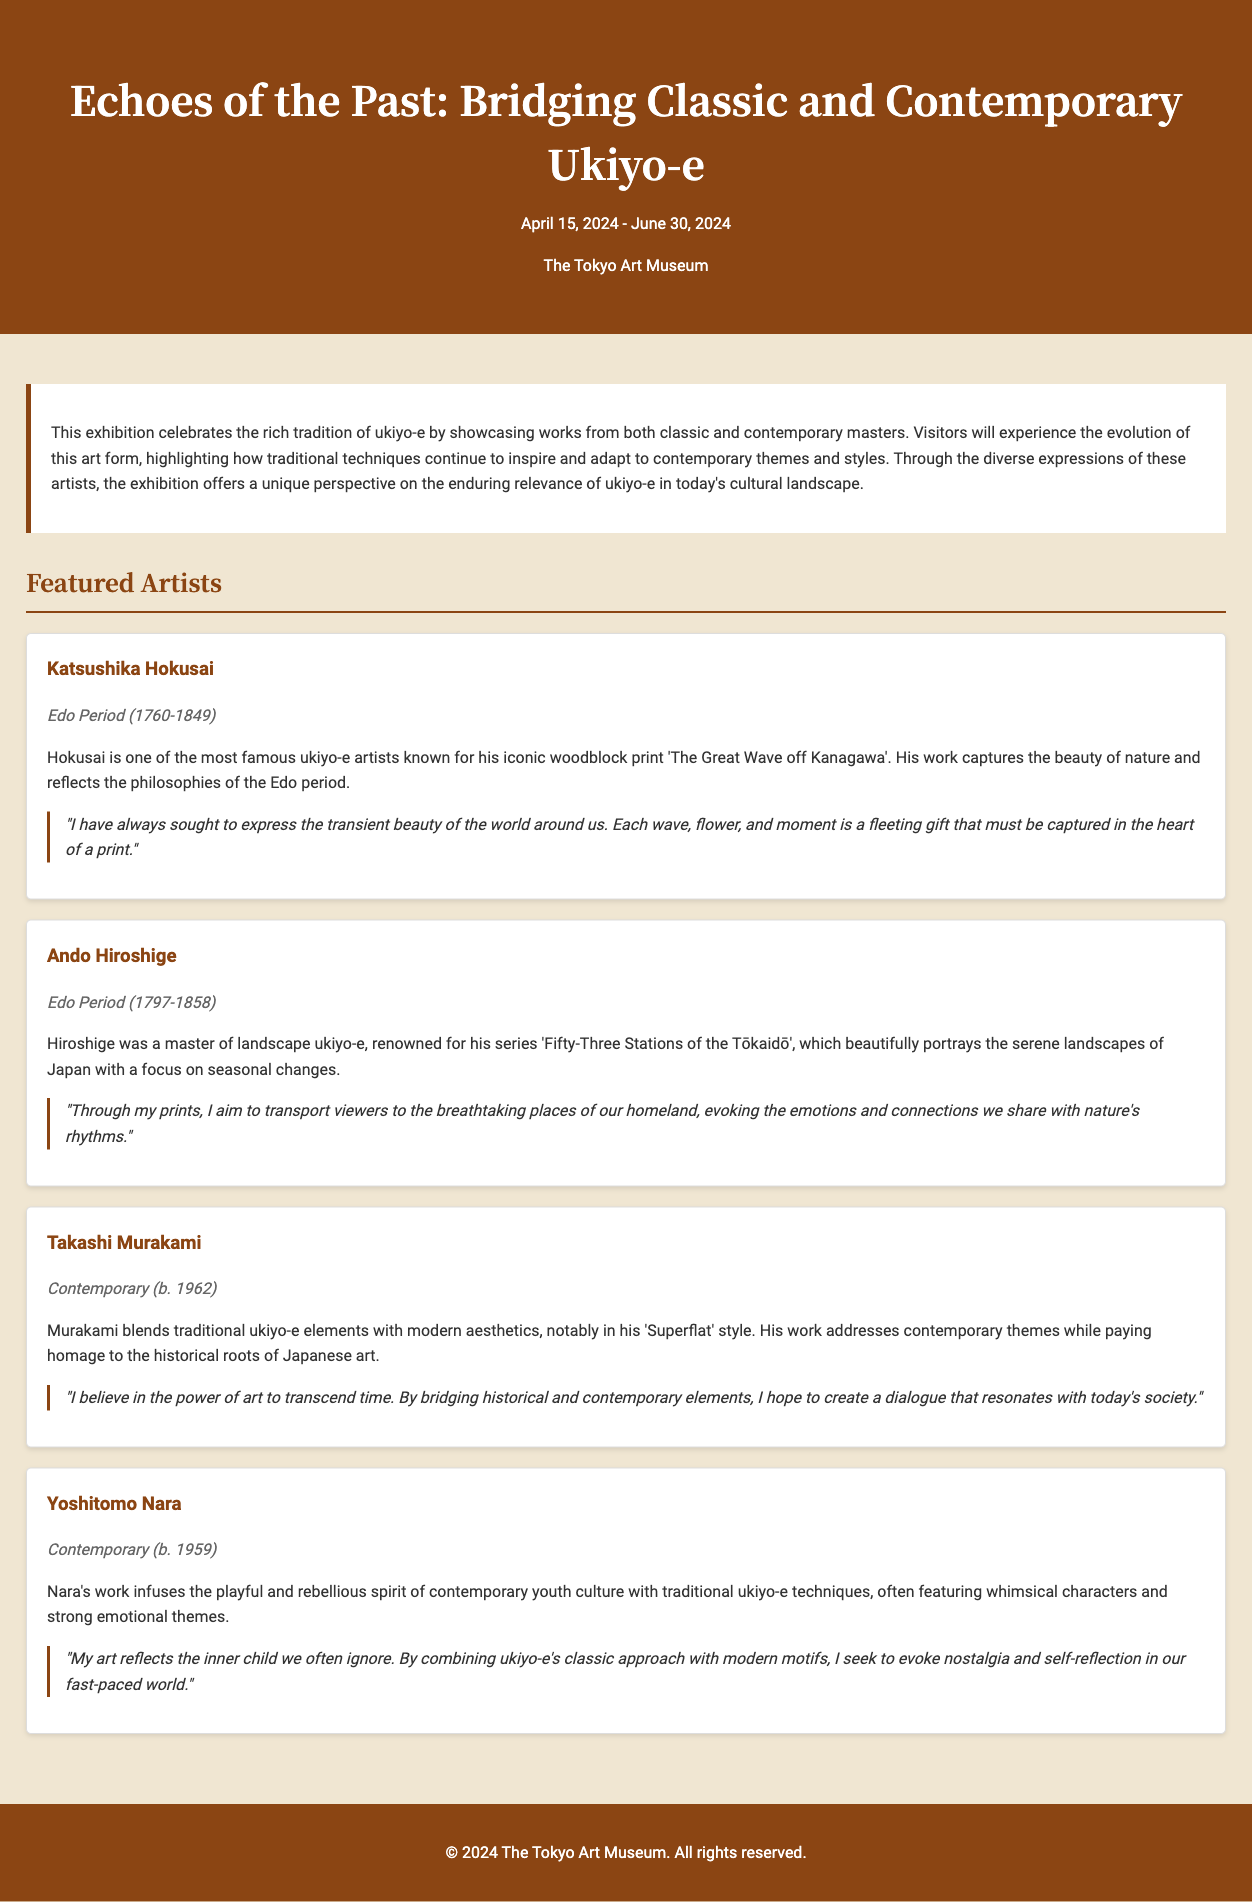What is the title of the exhibition? The title of the exhibition is presented prominently at the top of the document.
Answer: Echoes of the Past: Bridging Classic and Contemporary Ukiyo-e When does the exhibition start? The starting date of the exhibition is mentioned in the header section.
Answer: April 15, 2024 Who is the contemporary artist featured? The document lists notable contemporary artists featured in the exhibition.
Answer: Takashi Murakami What is Katsushika Hokusai known for? His notable work is detailed in the artist section of the document.
Answer: 'The Great Wave off Kanagawa' How many artists are featured in the exhibition? The document provides a list of artists featured under the "Featured Artists" section.
Answer: Four What period do Ando Hiroshige's works belong to? The artist era is mentioned clearly beneath his name in the document.
Answer: Edo Period What is the main theme of the exhibition? The theme is described in the exhibition info section at the beginning of the document.
Answer: The evolution of ukiyo-e What is Takashi Murakami's artistic style referred to as? The document includes a specific term used to describe his artwork.
Answer: Superflat What sentiment does Yoshitomo Nara's art aim to evoke? His artist statement in the document captures the intent of his work.
Answer: Nostalgia and self-reflection 